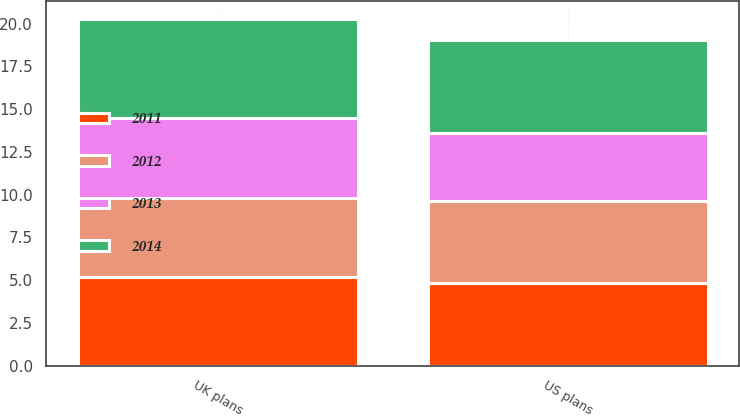Convert chart to OTSL. <chart><loc_0><loc_0><loc_500><loc_500><stacked_bar_chart><ecel><fcel>US plans<fcel>UK plans<nl><fcel>2012<fcel>4.83<fcel>4.6<nl><fcel>2013<fcel>3.97<fcel>4.7<nl><fcel>2011<fcel>4.82<fcel>5.2<nl><fcel>2014<fcel>5.42<fcel>5.8<nl></chart> 